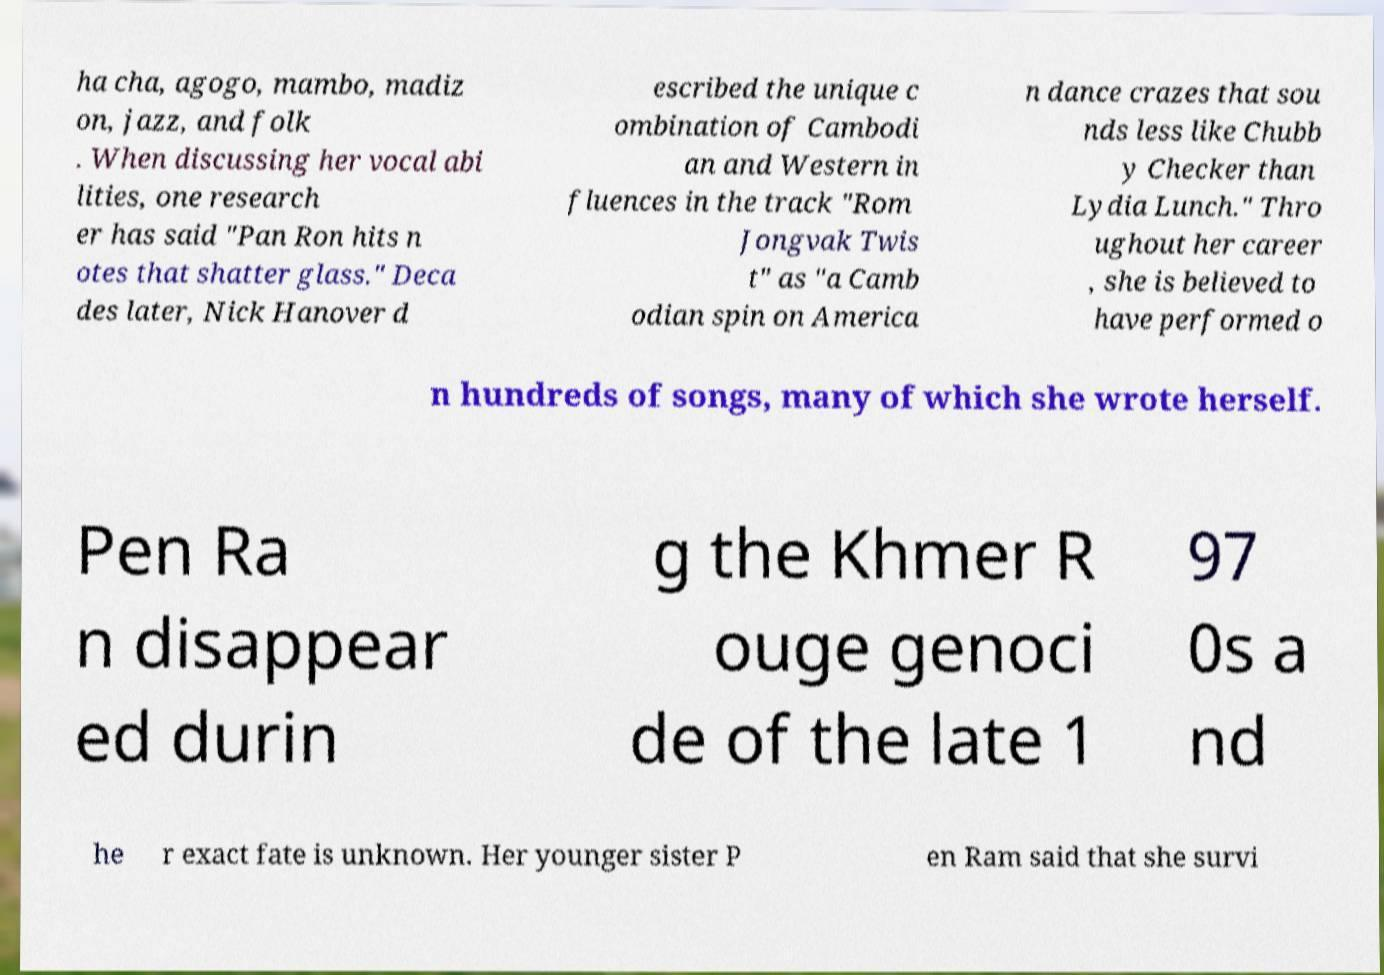I need the written content from this picture converted into text. Can you do that? ha cha, agogo, mambo, madiz on, jazz, and folk . When discussing her vocal abi lities, one research er has said "Pan Ron hits n otes that shatter glass." Deca des later, Nick Hanover d escribed the unique c ombination of Cambodi an and Western in fluences in the track "Rom Jongvak Twis t" as "a Camb odian spin on America n dance crazes that sou nds less like Chubb y Checker than Lydia Lunch." Thro ughout her career , she is believed to have performed o n hundreds of songs, many of which she wrote herself. Pen Ra n disappear ed durin g the Khmer R ouge genoci de of the late 1 97 0s a nd he r exact fate is unknown. Her younger sister P en Ram said that she survi 